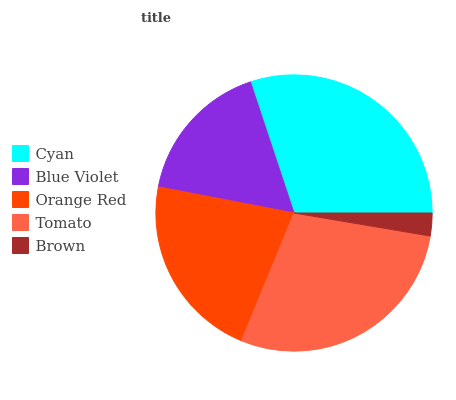Is Brown the minimum?
Answer yes or no. Yes. Is Cyan the maximum?
Answer yes or no. Yes. Is Blue Violet the minimum?
Answer yes or no. No. Is Blue Violet the maximum?
Answer yes or no. No. Is Cyan greater than Blue Violet?
Answer yes or no. Yes. Is Blue Violet less than Cyan?
Answer yes or no. Yes. Is Blue Violet greater than Cyan?
Answer yes or no. No. Is Cyan less than Blue Violet?
Answer yes or no. No. Is Orange Red the high median?
Answer yes or no. Yes. Is Orange Red the low median?
Answer yes or no. Yes. Is Blue Violet the high median?
Answer yes or no. No. Is Cyan the low median?
Answer yes or no. No. 